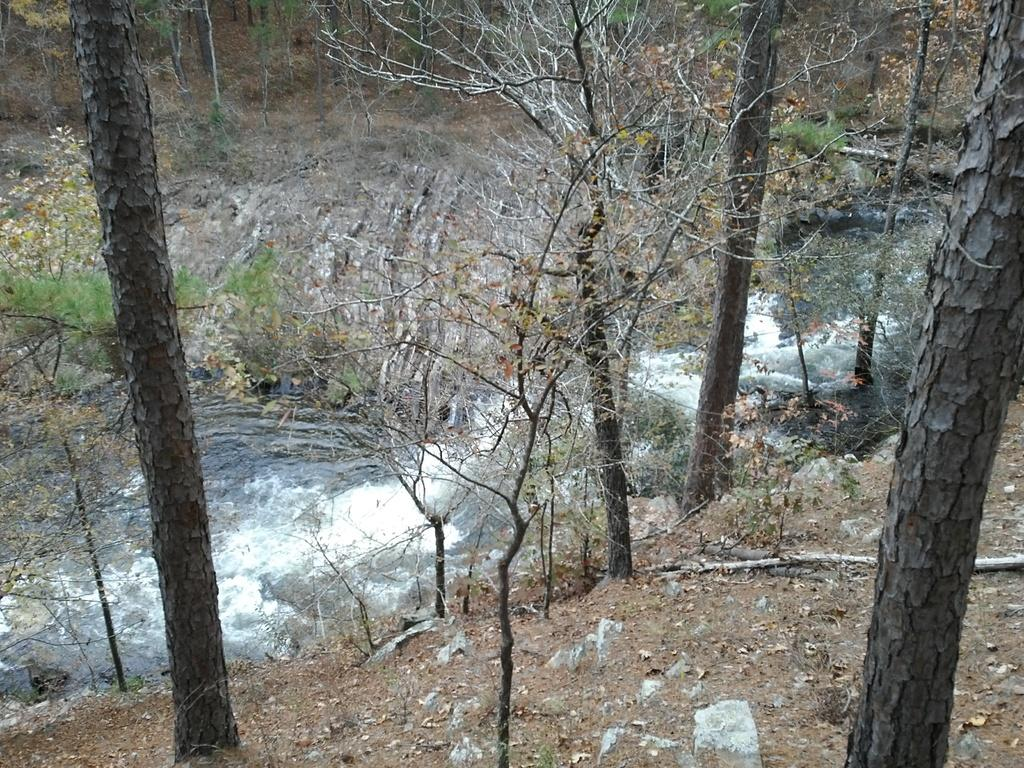What types of trees are present in the image? There are dried trees and green trees in the image. What other elements can be seen in the image besides trees? There are stones visible in the image. What type of band is performing in the image? There is no band present in the image; it features dried trees, green trees, and stones. How many divisions of the chicken can be seen in the image? There is no chicken present in the image, so it is not possible to determine the number of divisions. 